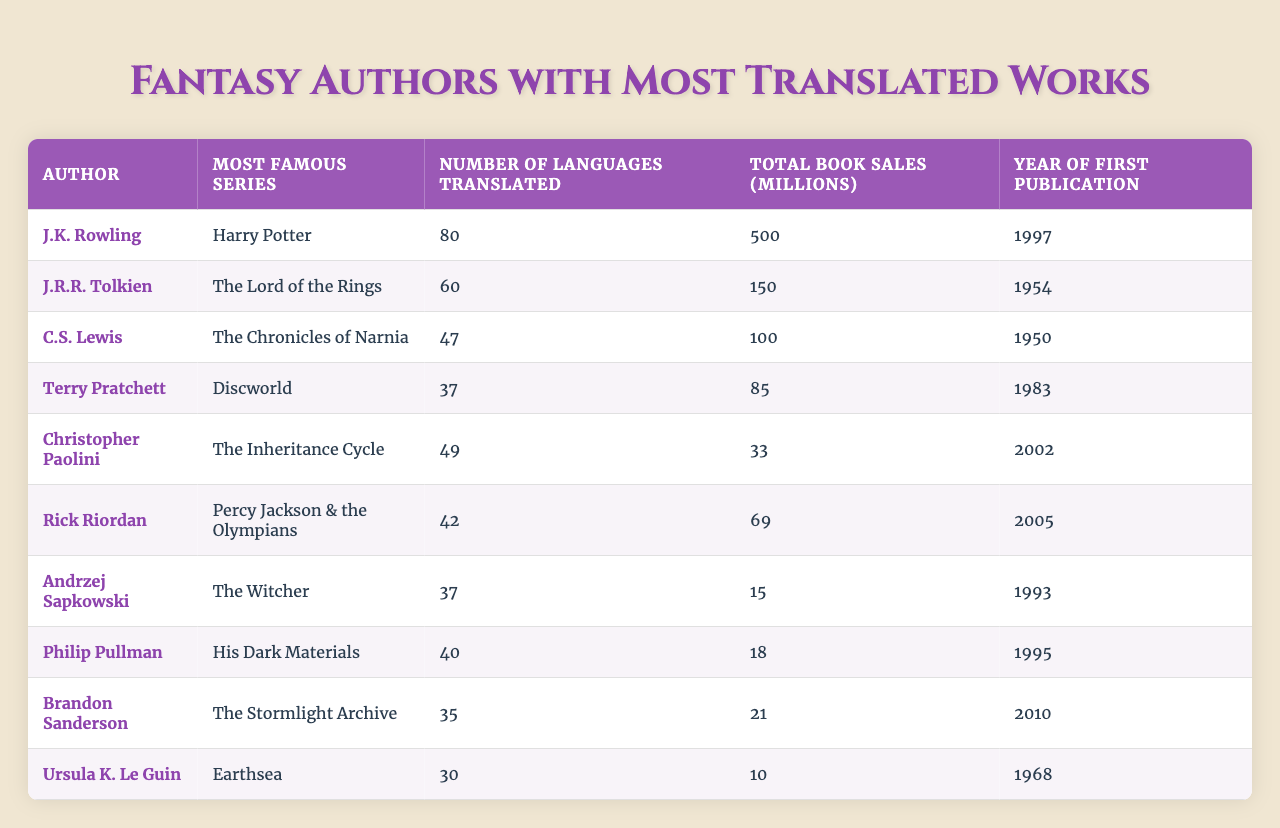What author has the highest number of languages translated? The table shows that J.K. Rowling has the highest number of languages translated, with a total of 80 languages.
Answer: J.K. Rowling Which author's most famous series is "The Lord of the Rings"? The table indicates that the most famous series for J.R.R. Tolkien is "The Lord of the Rings".
Answer: J.R.R. Tolkien How many languages was "His Dark Materials" translated into? The table shows that Philip Pullman's "His Dark Materials" was translated into 40 languages.
Answer: 40 True or false: Christopher Paolini has more total book sales than Terry Pratchett. The table lists Christopher Paolini with 33 million total book sales and Terry Pratchett with 85 million. Since 33 is less than 85, the statement is false.
Answer: False What is the average number of languages translated for all listed authors? To find the average, add all languages translated: 80 + 60 + 47 + 37 + 49 + 42 + 37 + 40 + 35 + 30 =  457. There are 10 authors, so the average is 457 / 10 = 45.7.
Answer: 45.7 Which author had their first publication in 2005? The table shows that Rick Riordan's first publication was in 2005, with "Percy Jackson & the Olympians".
Answer: Rick Riordan What is the difference in the number of languages translated between J.K. Rowling and Ursula K. Le Guin? J.K. Rowling has 80 languages and Ursula K. Le Guin has 30 languages. The difference is 80 - 30 = 50.
Answer: 50 Name the author with the second most total book sales. According to the table, J.K. Rowling (500 million) has the highest sales and J.R.R. Tolkien (150 million) is second.
Answer: J.R.R. Tolkien How many authors have more than 40 languages translated? From the table, the authors with more than 40 languages translated are J.K. Rowling, J.R.R. Tolkien, C.S. Lewis, Rick Riordan, and Philip Pullman, totaling 5 authors.
Answer: 5 Is the total book sales of Andrzej Sapkowski greater than that of Philip Pullman? The table shows Andrzej Sapkowski with 15 million and Philip Pullman with 18 million. Since 15 is less than 18, the statement is false.
Answer: False 